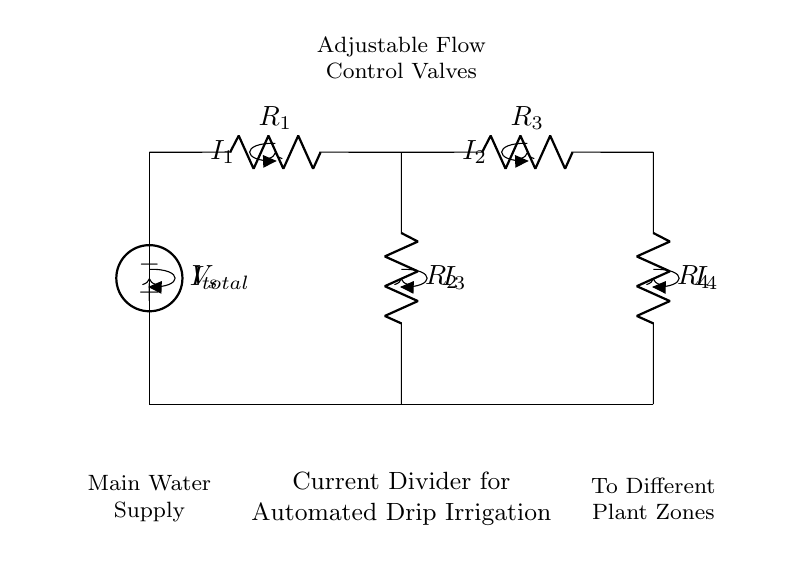What is the total current entering the circuit? The total current, denoted as I total, is the current supplied from the main water supply to the circuit. It can be visually identified in the circuit diagram, which indicates it is the primary input current.
Answer: I total How many resistors are present in this current divider network? The circuit diagram shows a total of four resistors labeled R1, R2, R3, and R4. They are represented as series components in the circuit design, which specifies the current distribution.
Answer: Four What is the purpose of the adjustable flow control valves depicted in the diagram? The adjustable flow control valves are used to regulate the flow rates of water, allowing customized irrigation levels for different plant zones. This function is visually indicated in the diagram where the valves are notations associated with the water flow.
Answer: Regulate flow rates Which resistor(s) might receive the highest current according to the current divider principle? The resistor with the lowest resistance will receive the highest current based on the current divider principle. This is due to the nature of current division where current tends to flow more through paths with lesser resistance.
Answer: R2 or R4 (depending on their values) Which component is directly connected to the main water supply? The component directly connected to the main water supply is the voltage source, which serves as the origin of the current in the circuit. It's identifiable by its position at the top of the diagram.
Answer: Voltage source What is the significance of the arrows indicating current direction in the circuit? The arrows indicate the direction of current flow through the components of the circuit. They can help visualize how the current divides among the resistors, which is crucial for understanding the operational effectiveness of the irrigation system.
Answer: Indicate current flow 